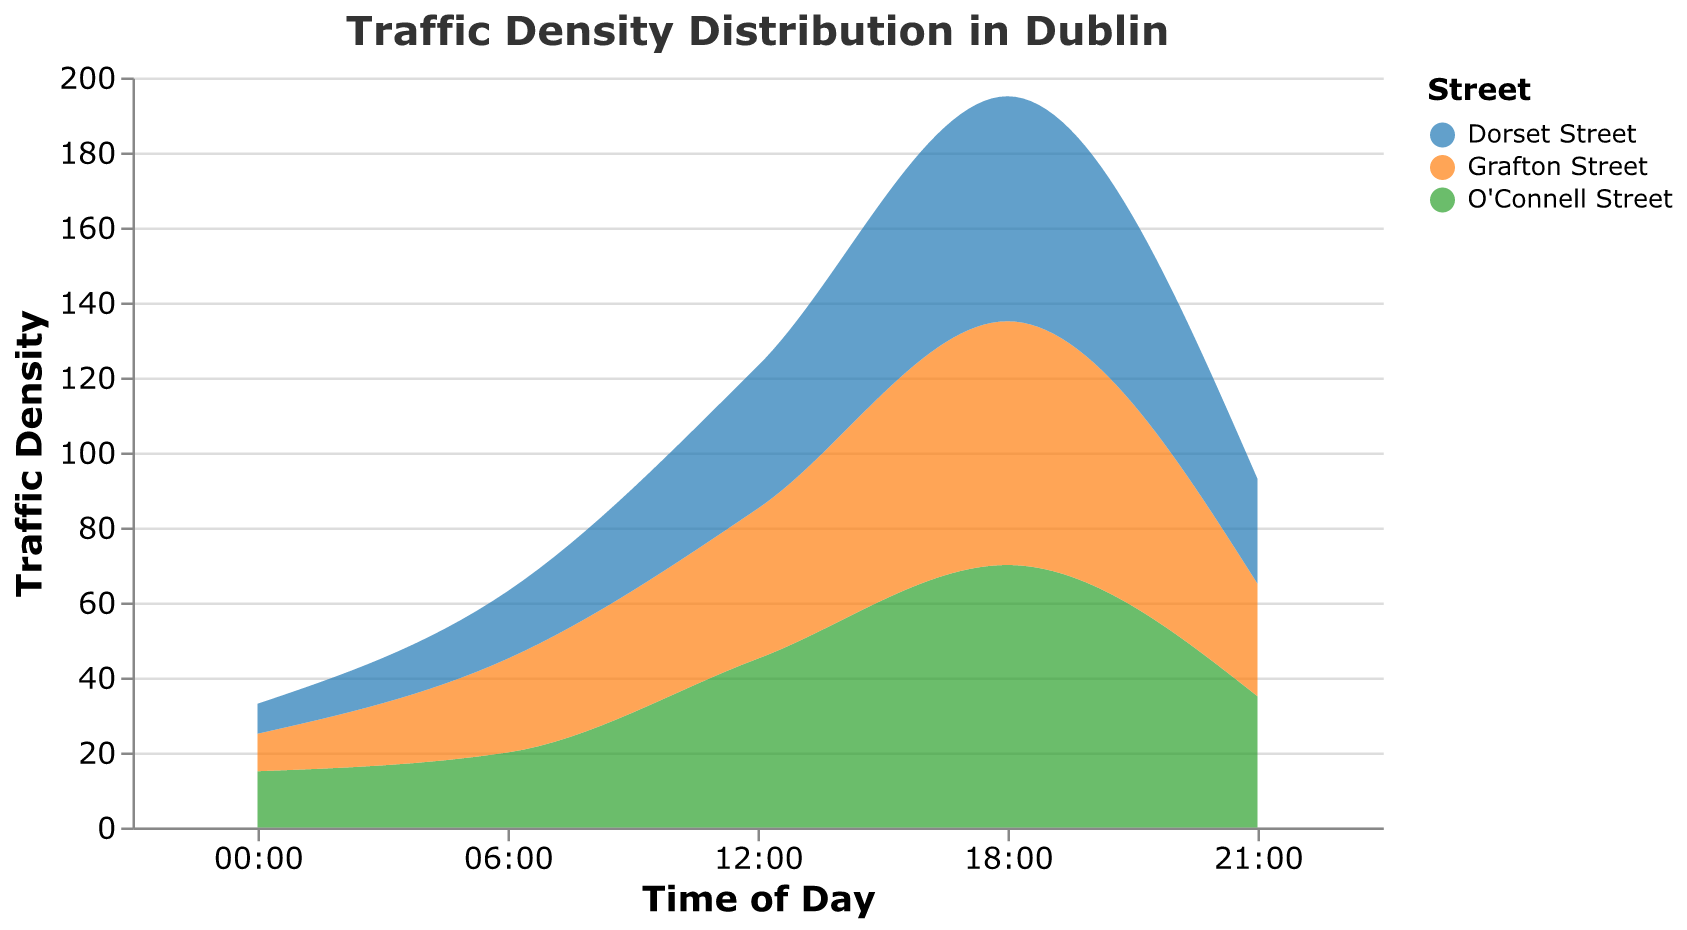What time of day has the highest traffic density?\ The highest traffic density is observed at 18:00, which can be seen as the peak in the data across all locations.\
Answer: 18:00 What is the traffic density on Dorset Street at 12:00?\ The traffic density on Dorset Street at 12:00 is provided in the plot and can be found by looking at the value associated with Dorset Street at that time. The value is 38.\
Answer: 38 Which location has the lowest traffic density at 00:00?\ To determine the location with the lowest traffic density at 00:00, compare the traffic densities for all locations at this time. Dorset Street has the lowest traffic density of 8.\
Answer: Dorset Street How does the traffic density on Grafton Street at 06:00 compare to that at 18:00?\ Find the traffic density values for Grafton Street at both times: 25 at 06:00 and 65 at 18:00. Grafton Street has a higher traffic density at 18:00 compared to 06:00.\
Answer: Higher at 18:00 What is the difference in traffic density between O'Connell Street and Grafton Street at 21:00?\ At 21:00, the traffic densities are 35 for O'Connell Street and 30 for Grafton Street. Subtract the traffic density of Grafton Street from O'Connell Street: 35 - 30 = 5.\
Answer: 5 What general trend can you observe across all locations from 00:00 to 18:00?\ Observe the traffic density values for all times: the values generally increase from 00:00 to 18:00, indicating a rise in traffic density towards the evening. After 18:00, they tend to decrease.\
Answer: Increasing Which location shows the most significant increase in traffic density from 12:00 to 18:00?\ Compare the traffic density values at 12:00 and 18:00 for each location. O'Connell Street shows the most significant increase (45 to 70, a difference of 25).\
Answer: O'Connell Street At which time of day do all three locations have the closest traffic densities?\ Look at the traffic density values at each time: at 06:00, the values are 20, 25, and 18 - the smallest range of differences across all the times mentioned.\
Answer: 06:00 